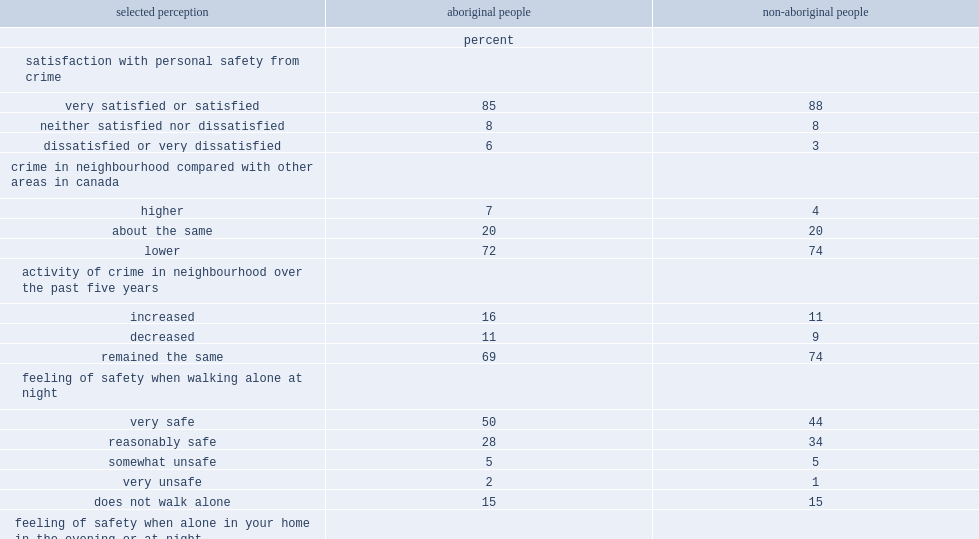In 2014, what was ther percent of aboriginal people reported being satisfied or very satisfied with their personal safety from crime? 85.0. In 2014, what was ther percent of non-aboriginal people reported being satisfied or very satisfied with their personal safety from crime? 88.0. When considering crime in one's neighbourhood, which kind of people believed that there was a higher amount of crime in their neighbourhood compared to other areas of canada, aboriginal people or non-aboriginal people? Aboriginal people. What was the percent of aboriginal people reported feeling very safe when walking alone at night? 50.0. What was the percent of non-aboriginal people reported feeling very safe when walking alone at night? 44.0. 